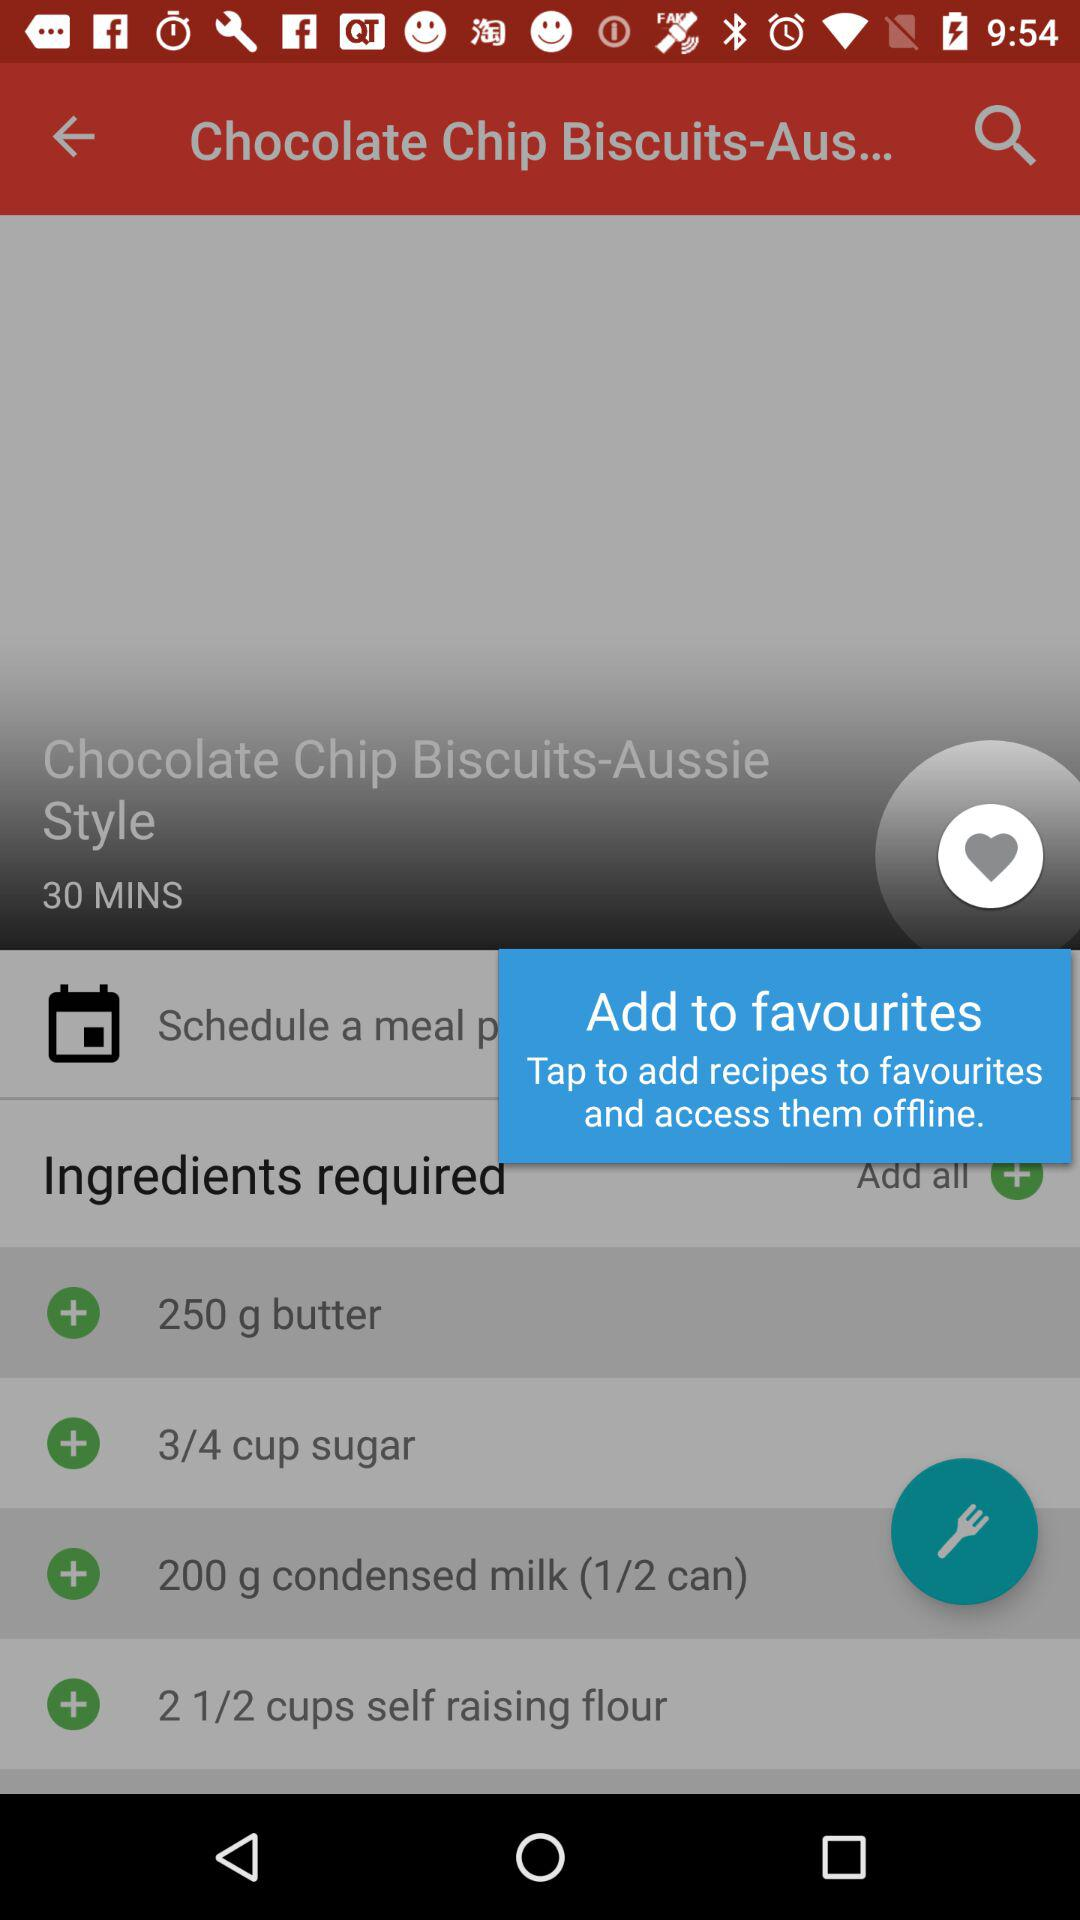What is the dish name? The dish name is "Chocolate Chip Biscuits-Aussie Style". 